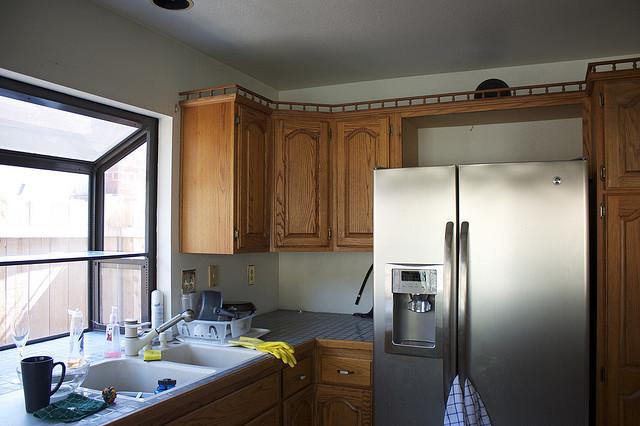How many doors are in that picture, cabinet or otherwise?
Concise answer only. 10. Is the window a bay window?
Be succinct. Yes. Does the fridge have a water dispenser?
Keep it brief. Yes. What room is this?
Quick response, please. Kitchen. 